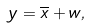<formula> <loc_0><loc_0><loc_500><loc_500>y = \overline { x } + w ,</formula> 